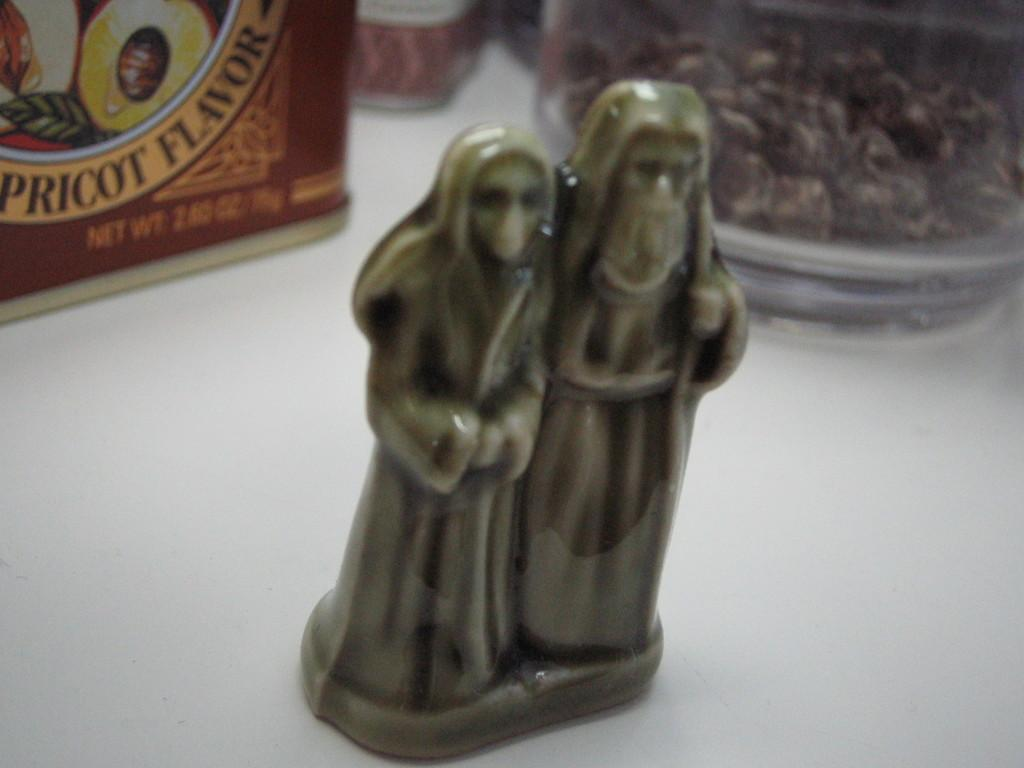What is the main subject of the image? There is a statue of two humans in the image. Where is the statue located? The statue is on a table. What else can be seen in the image? There are food bowls behind the statue. How many ladybugs can be seen on the statue in the image? There are no ladybugs present on the statue in the image. What type of health benefits does the mint in the image provide? There is no mint present in the image. 